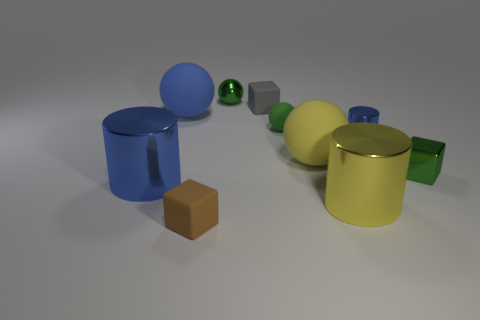Subtract 1 balls. How many balls are left? 3 Subtract all blocks. How many objects are left? 7 Add 5 large green metallic blocks. How many large green metallic blocks exist? 5 Subtract 0 gray spheres. How many objects are left? 10 Subtract all tiny gray metallic cylinders. Subtract all shiny cubes. How many objects are left? 9 Add 7 tiny matte things. How many tiny matte things are left? 10 